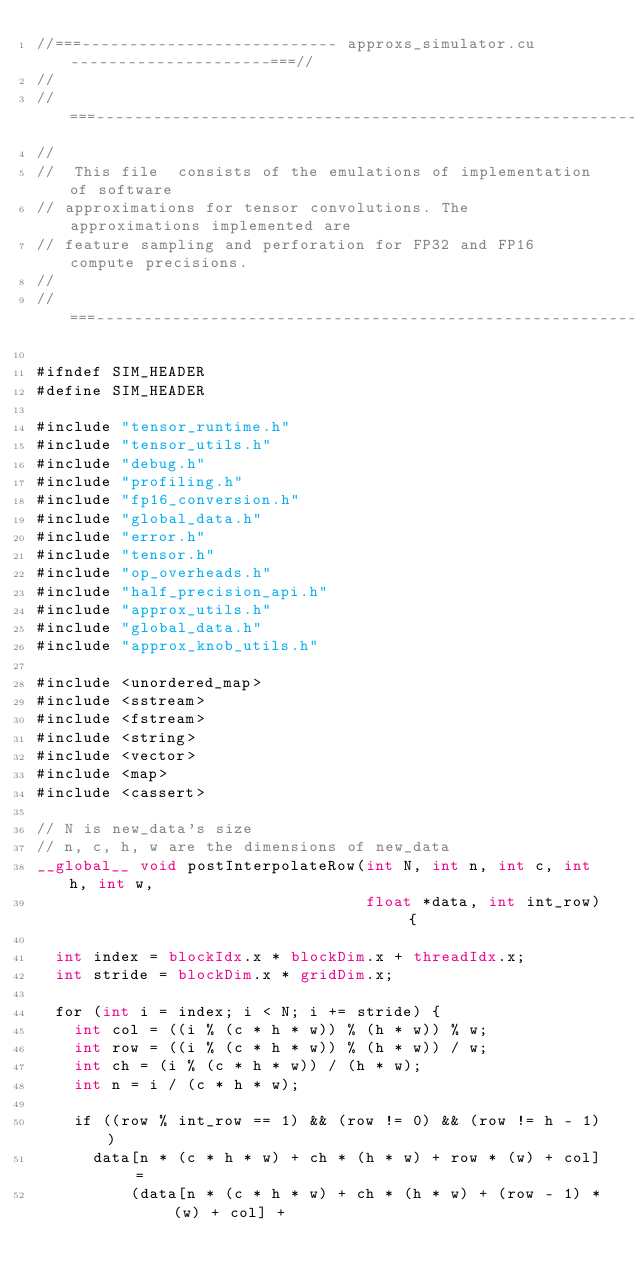<code> <loc_0><loc_0><loc_500><loc_500><_Cuda_>//===--------------------------- approxs_simulator.cu ---------------------===//
//
//===----------------------------------------------------------------------===//
//
//  This file  consists of the emulations of implementation of software
// approximations for tensor convolutions. The approximations implemented are
// feature sampling and perforation for FP32 and FP16 compute precisions.
//
//===----------------------------------------------------------------------===//

#ifndef SIM_HEADER
#define SIM_HEADER

#include "tensor_runtime.h"
#include "tensor_utils.h"
#include "debug.h"
#include "profiling.h"
#include "fp16_conversion.h"
#include "global_data.h"
#include "error.h"
#include "tensor.h"
#include "op_overheads.h"
#include "half_precision_api.h"
#include "approx_utils.h"
#include "global_data.h"
#include "approx_knob_utils.h"

#include <unordered_map>
#include <sstream>
#include <fstream>
#include <string>
#include <vector>
#include <map>
#include <cassert>

// N is new_data's size
// n, c, h, w are the dimensions of new_data
__global__ void postInterpolateRow(int N, int n, int c, int h, int w,
                                   float *data, int int_row) {

  int index = blockIdx.x * blockDim.x + threadIdx.x;
  int stride = blockDim.x * gridDim.x;

  for (int i = index; i < N; i += stride) {
    int col = ((i % (c * h * w)) % (h * w)) % w;
    int row = ((i % (c * h * w)) % (h * w)) / w;
    int ch = (i % (c * h * w)) / (h * w);
    int n = i / (c * h * w);

    if ((row % int_row == 1) && (row != 0) && (row != h - 1))
      data[n * (c * h * w) + ch * (h * w) + row * (w) + col] =
          (data[n * (c * h * w) + ch * (h * w) + (row - 1) * (w) + col] +</code> 